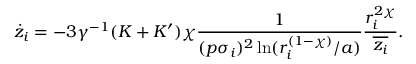<formula> <loc_0><loc_0><loc_500><loc_500>\dot { z } _ { i } = - 3 \gamma ^ { - 1 } ( K + K ^ { \prime } ) \chi \frac { 1 } { ( p \sigma _ { i } ) ^ { 2 } \ln ( r _ { i } ^ { ( 1 - \chi ) } / a ) } \frac { r _ { i } ^ { 2 \chi } } { \overline { { z _ { i } } } } .</formula> 